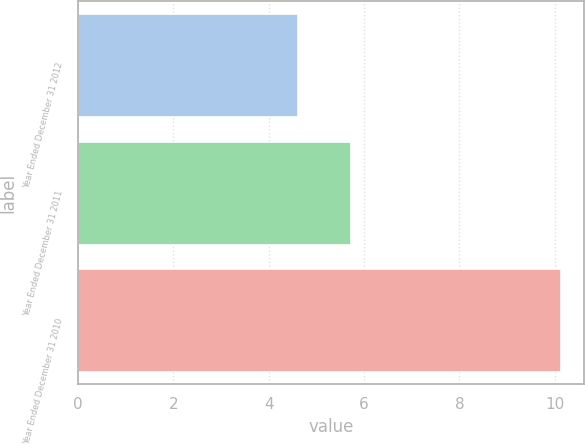<chart> <loc_0><loc_0><loc_500><loc_500><bar_chart><fcel>Year Ended December 31 2012<fcel>Year Ended December 31 2011<fcel>Year Ended December 31 2010<nl><fcel>4.6<fcel>5.7<fcel>10.1<nl></chart> 